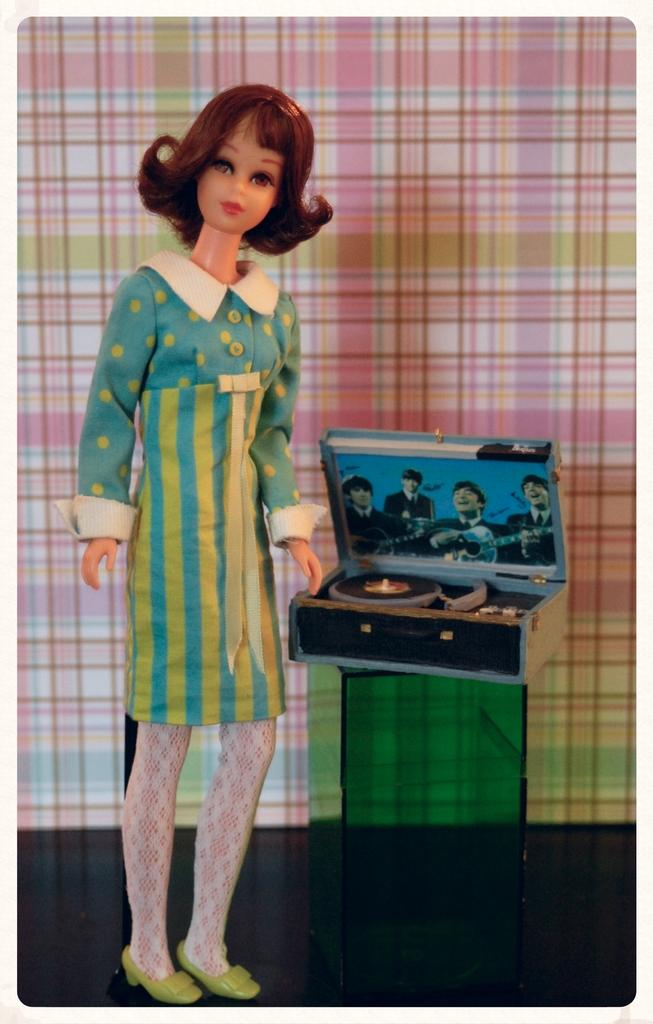What is located on the left side of the image? There is a doll on the left side of the image. What can be seen inside the box on a stand in the image? The objects inside the box on a stand are not visible in the image. What is visible in the background of the image? There are designs on a platform in the background of the image. What is the reason for the doll's elbow being bent in the image? The doll's elbow is not bent in the image, and there is no reason to discuss its elbow since it is not a relevant detail in the image. 